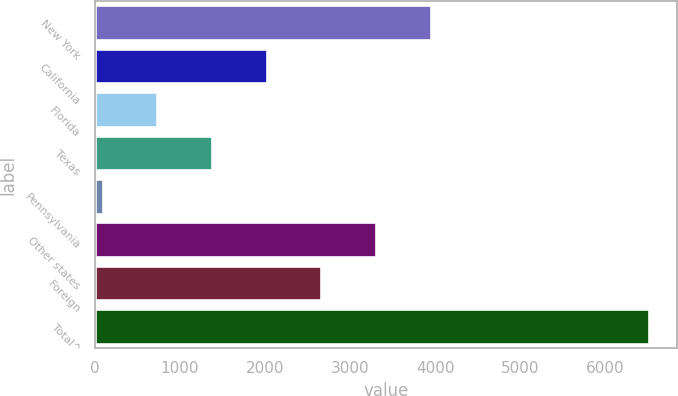Convert chart. <chart><loc_0><loc_0><loc_500><loc_500><bar_chart><fcel>New York<fcel>California<fcel>Florida<fcel>Texas<fcel>Pennsylvania<fcel>Other states<fcel>Foreign<fcel>Total^<nl><fcel>3946.4<fcel>2017.7<fcel>731.9<fcel>1374.8<fcel>89<fcel>3303.5<fcel>2660.6<fcel>6518<nl></chart> 